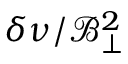Convert formula to latex. <formula><loc_0><loc_0><loc_500><loc_500>\delta \nu / \mathcal { B } _ { \perp } ^ { 2 }</formula> 